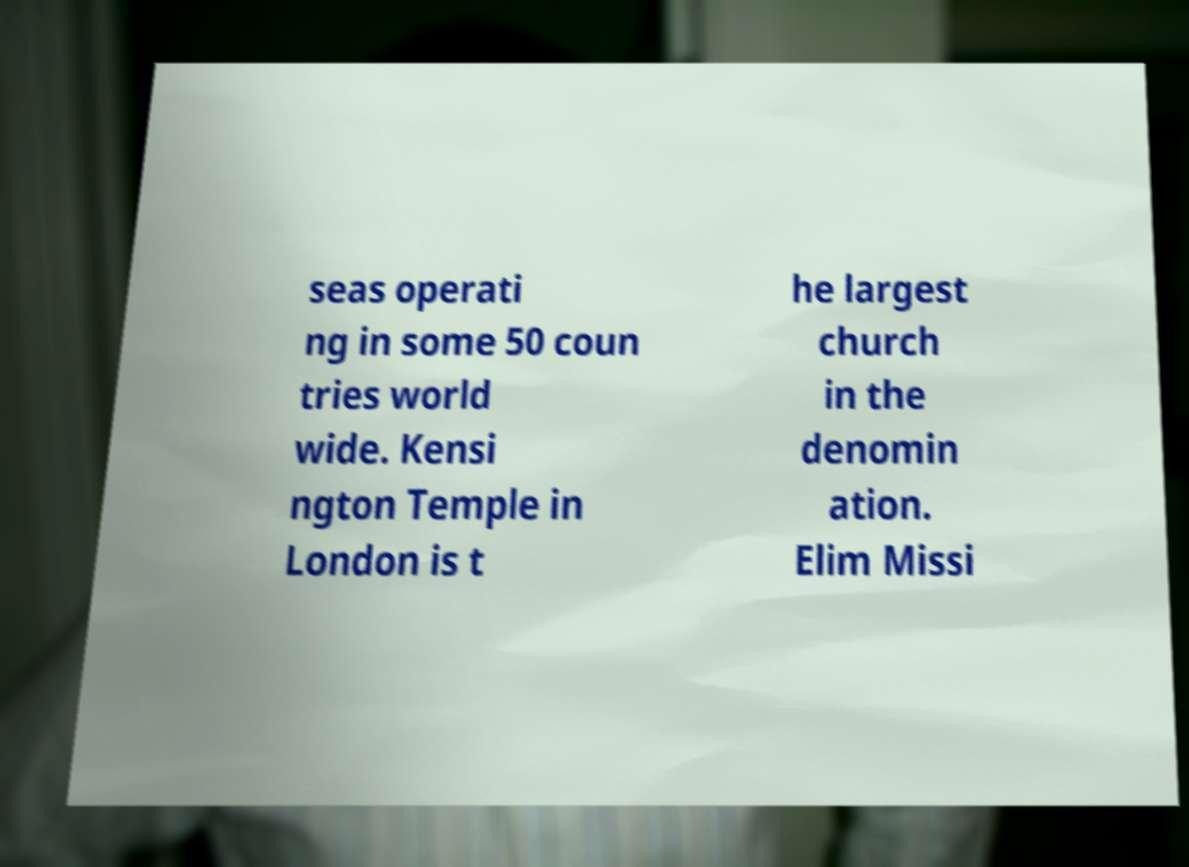Could you assist in decoding the text presented in this image and type it out clearly? seas operati ng in some 50 coun tries world wide. Kensi ngton Temple in London is t he largest church in the denomin ation. Elim Missi 